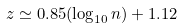<formula> <loc_0><loc_0><loc_500><loc_500>z \simeq 0 . 8 5 ( \log _ { 1 0 } n ) + 1 . 1 2</formula> 